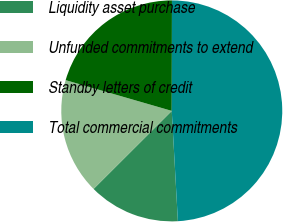Convert chart. <chart><loc_0><loc_0><loc_500><loc_500><pie_chart><fcel>Liquidity asset purchase<fcel>Unfunded commitments to extend<fcel>Standby letters of credit<fcel>Total commercial commitments<nl><fcel>13.4%<fcel>16.97%<fcel>20.54%<fcel>49.09%<nl></chart> 